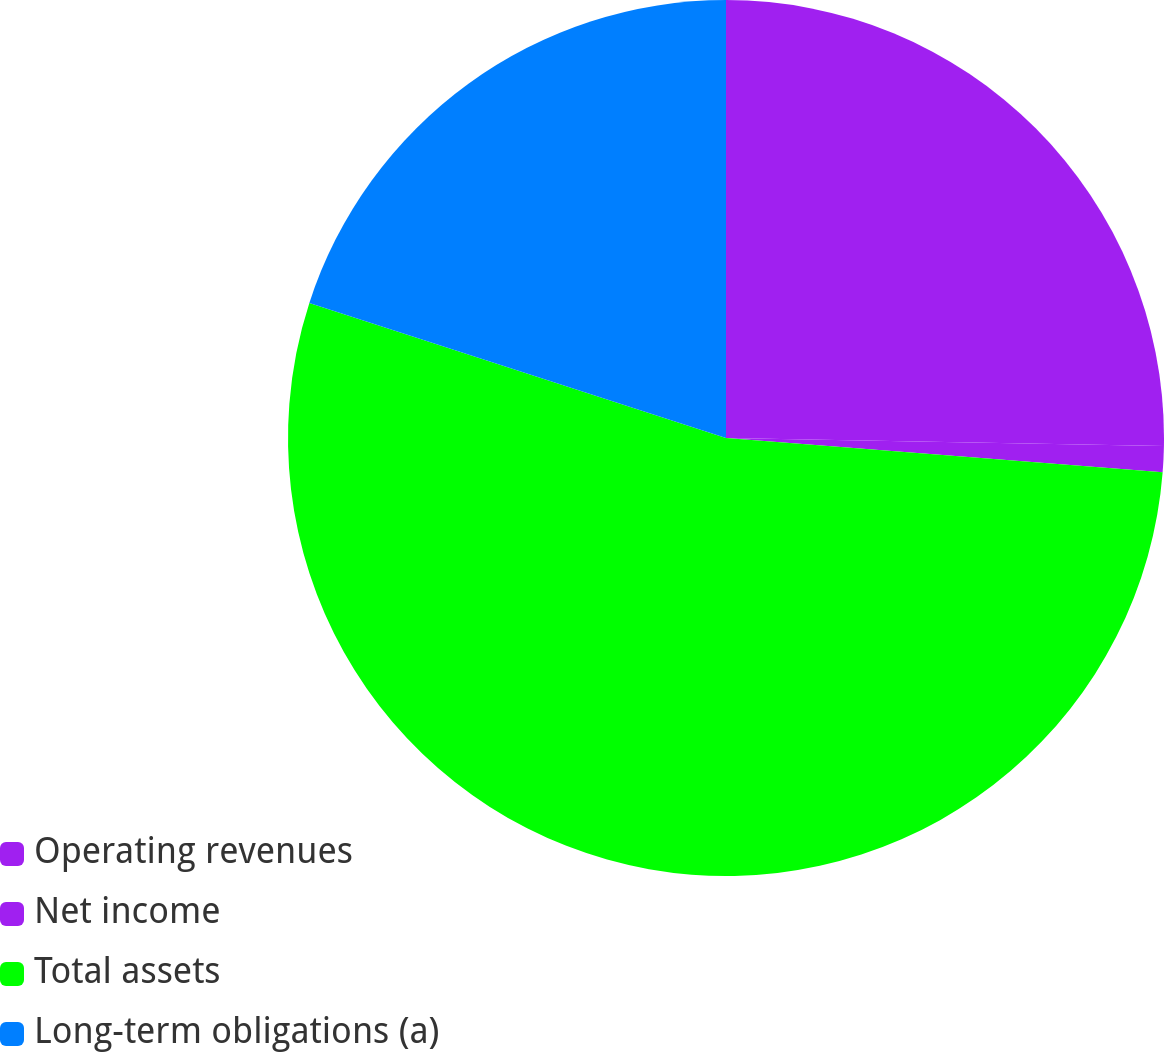Convert chart. <chart><loc_0><loc_0><loc_500><loc_500><pie_chart><fcel>Operating revenues<fcel>Net income<fcel>Total assets<fcel>Long-term obligations (a)<nl><fcel>25.29%<fcel>0.96%<fcel>53.74%<fcel>20.01%<nl></chart> 